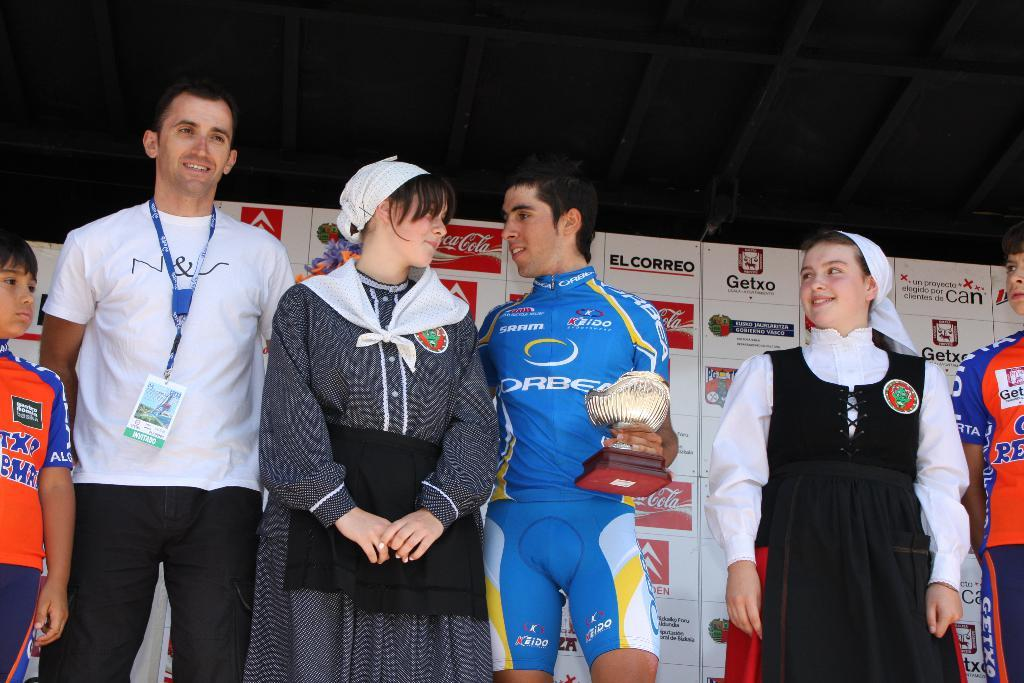<image>
Present a compact description of the photo's key features. Some people standing together; the word Getxo is visible on a sign in the background. 